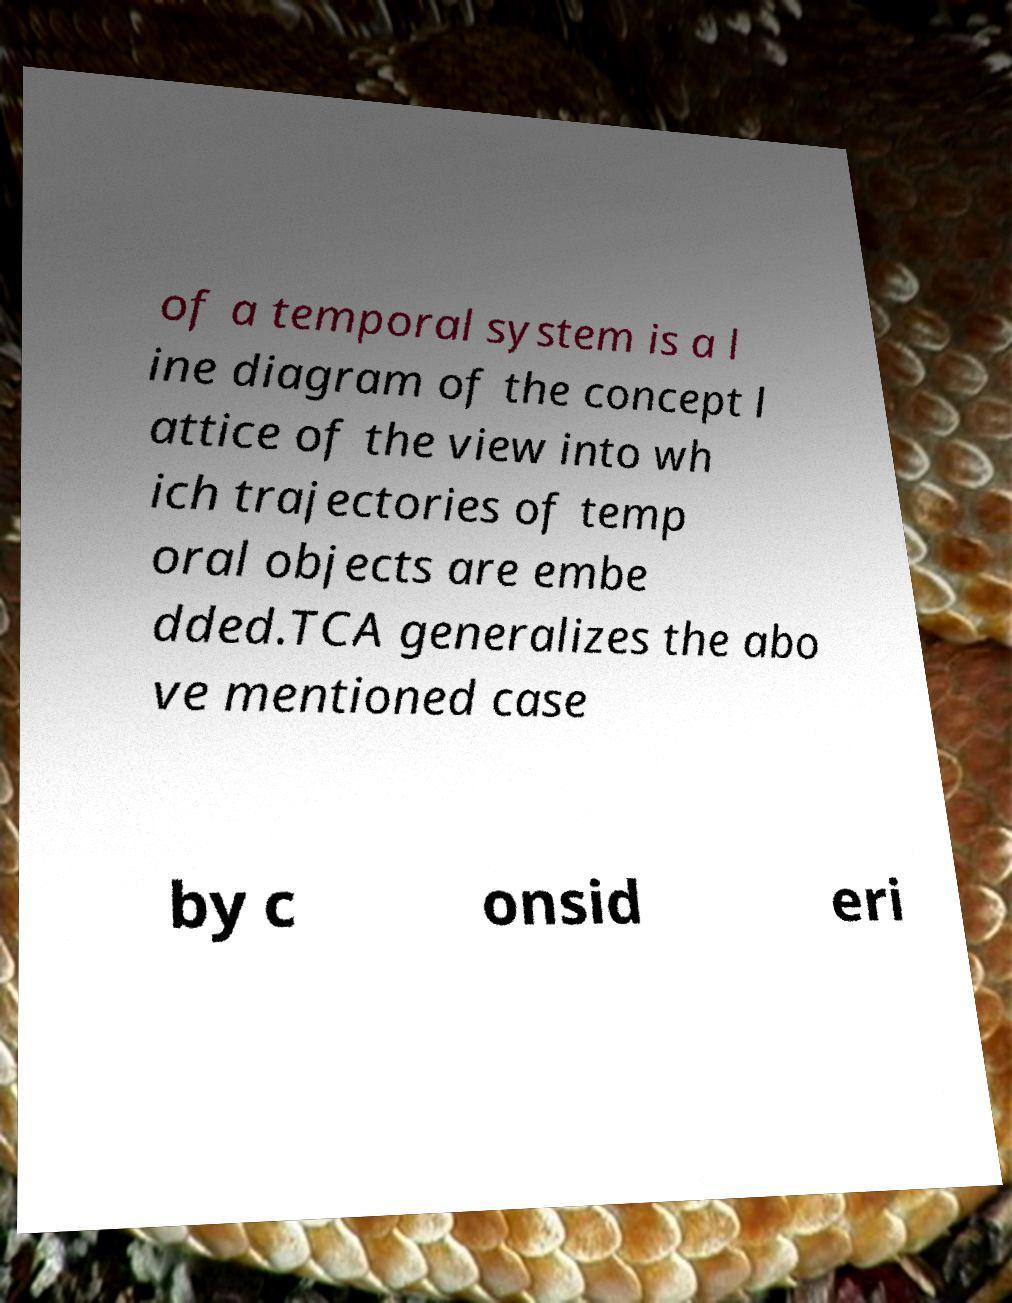There's text embedded in this image that I need extracted. Can you transcribe it verbatim? of a temporal system is a l ine diagram of the concept l attice of the view into wh ich trajectories of temp oral objects are embe dded.TCA generalizes the abo ve mentioned case by c onsid eri 